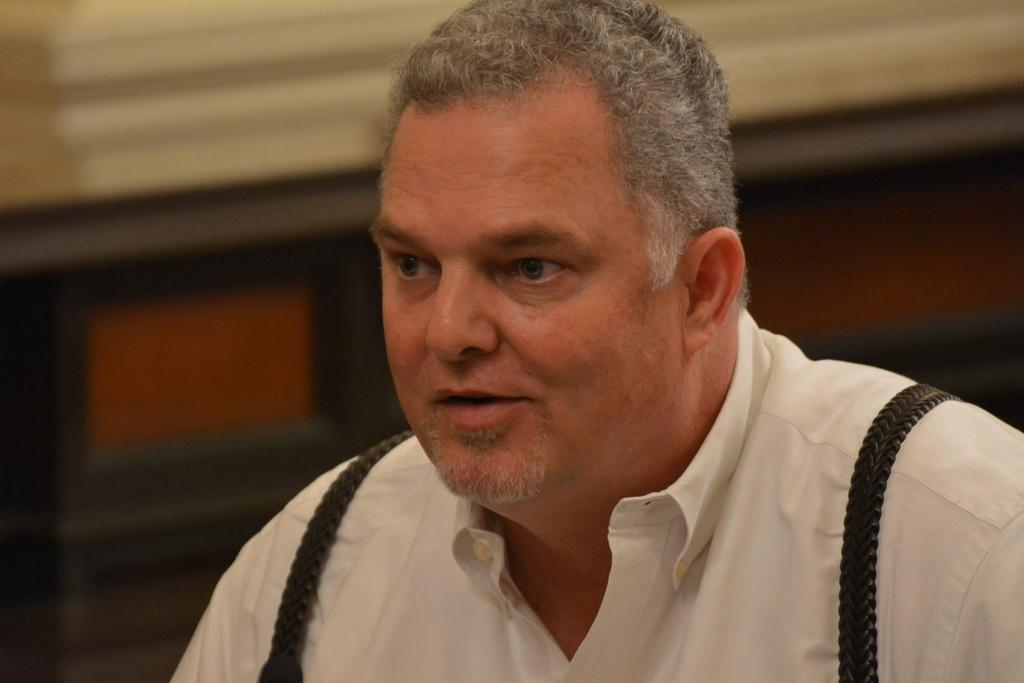What is the main subject of the image? There is a person in the image. What is the person wearing in the image? The person is wearing a white shirt. Can you describe the background of the image? The background of the image is blurry. What type of regret can be seen on the person's face in the image? There is no indication of regret on the person's face in the image. What type of seed is being planted by the person in the image? There is no seed or planting activity present in the image. What type of fictional character is the person in the image portraying? There is no indication that the person is portraying a fictional character in the image. 